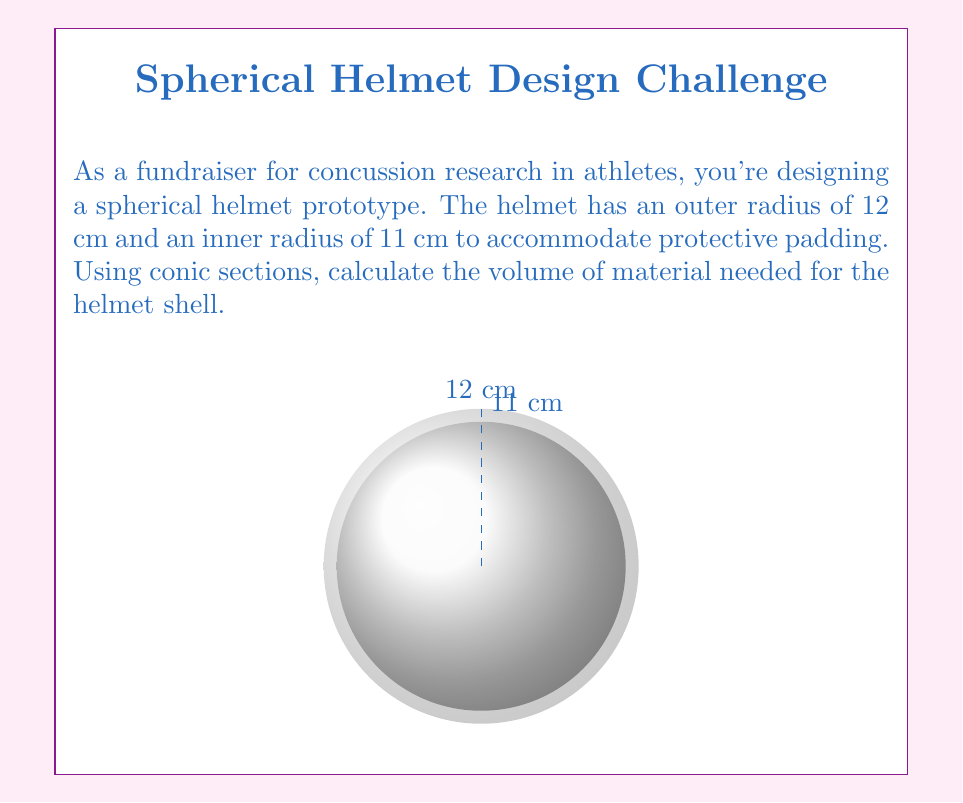Can you answer this question? Let's approach this step-by-step using conic sections:

1) The helmet shell is the difference between two spheres. We can use the formula for the volume of a sphere, which is derived from rotating a semicircle (a conic section) around its diameter:

   $$V_{sphere} = \frac{4}{3}\pi r^3$$

2) For the outer sphere (radius 12 cm):
   $$V_{outer} = \frac{4}{3}\pi (12)^3 = \frac{4}{3}\pi (1728) = 2304\pi \text{ cm}^3$$

3) For the inner sphere (radius 11 cm):
   $$V_{inner} = \frac{4}{3}\pi (11)^3 = \frac{4}{3}\pi (1331) = 1774.67\pi \text{ cm}^3$$

4) The volume of the helmet shell is the difference:
   $$V_{shell} = V_{outer} - V_{inner}$$
   $$V_{shell} = 2304\pi - 1774.67\pi = 529.33\pi \text{ cm}^3$$

5) Simplifying:
   $$V_{shell} = 1662.76 \text{ cm}^3$$

Therefore, the volume of material needed for the helmet shell is approximately 1662.76 cubic centimeters.
Answer: $1662.76 \text{ cm}^3$ 